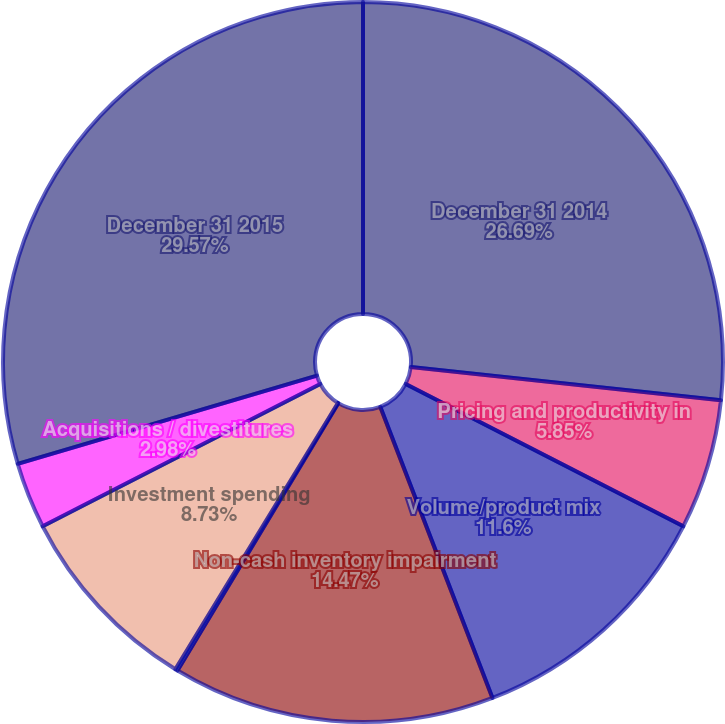Convert chart. <chart><loc_0><loc_0><loc_500><loc_500><pie_chart><fcel>December 31 2014<fcel>Pricing and productivity in<fcel>Volume/product mix<fcel>Non-cash inventory impairment<fcel>Currency exchange rates<fcel>Investment spending<fcel>Acquisitions / divestitures<fcel>December 31 2015<nl><fcel>26.69%<fcel>5.85%<fcel>11.6%<fcel>14.47%<fcel>0.11%<fcel>8.73%<fcel>2.98%<fcel>29.56%<nl></chart> 